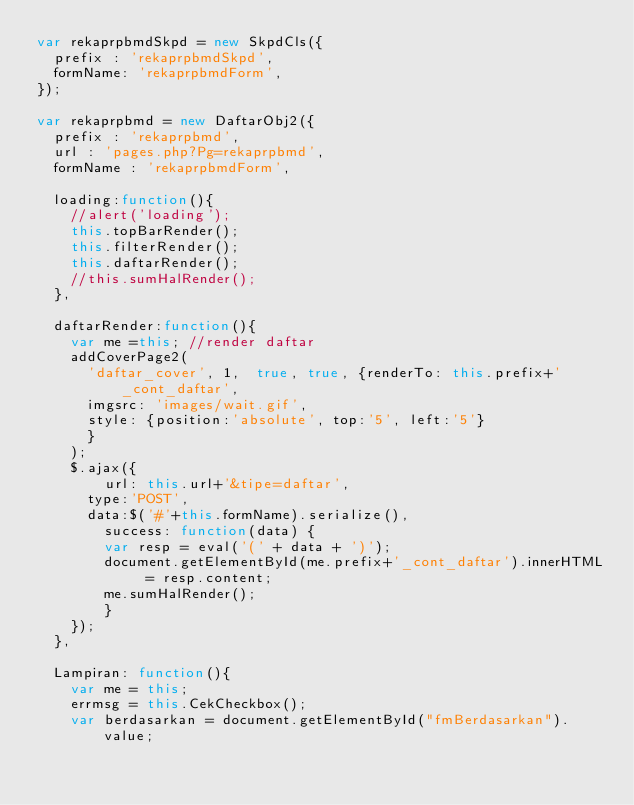Convert code to text. <code><loc_0><loc_0><loc_500><loc_500><_JavaScript_>var rekaprpbmdSkpd = new SkpdCls({
	prefix : 'rekaprpbmdSkpd', 
	formName: 'rekaprpbmdForm',
});

var rekaprpbmd = new DaftarObj2({
	prefix : 'rekaprpbmd',
	url : 'pages.php?Pg=rekaprpbmd', 
	formName : 'rekaprpbmdForm',
	
	loading:function(){
		//alert('loading');
		this.topBarRender();
		this.filterRender();
		this.daftarRender();
		//this.sumHalRender();
	},
		
	daftarRender:function(){
		var me =this; //render daftar 
		addCoverPage2(
			'daftar_cover',	1, 	true, true,	{renderTo: this.prefix+'_cont_daftar',
			imgsrc: 'images/wait.gif',
			style: {position:'absolute', top:'5', left:'5'}
			}
		);
		$.ajax({
		  	url: this.url+'&tipe=daftar',
		 	type:'POST', 
			data:$('#'+this.formName).serialize(), 
		  	success: function(data) {		
				var resp = eval('(' + data + ')');
				document.getElementById(me.prefix+'_cont_daftar').innerHTML = resp.content;
				me.sumHalRender();
		  	}
		});
	},
	
	Lampiran: function(){		
		var me = this;
		errmsg = this.CekCheckbox();	
		var berdasarkan = document.getElementById("fmBerdasarkan").value;</code> 